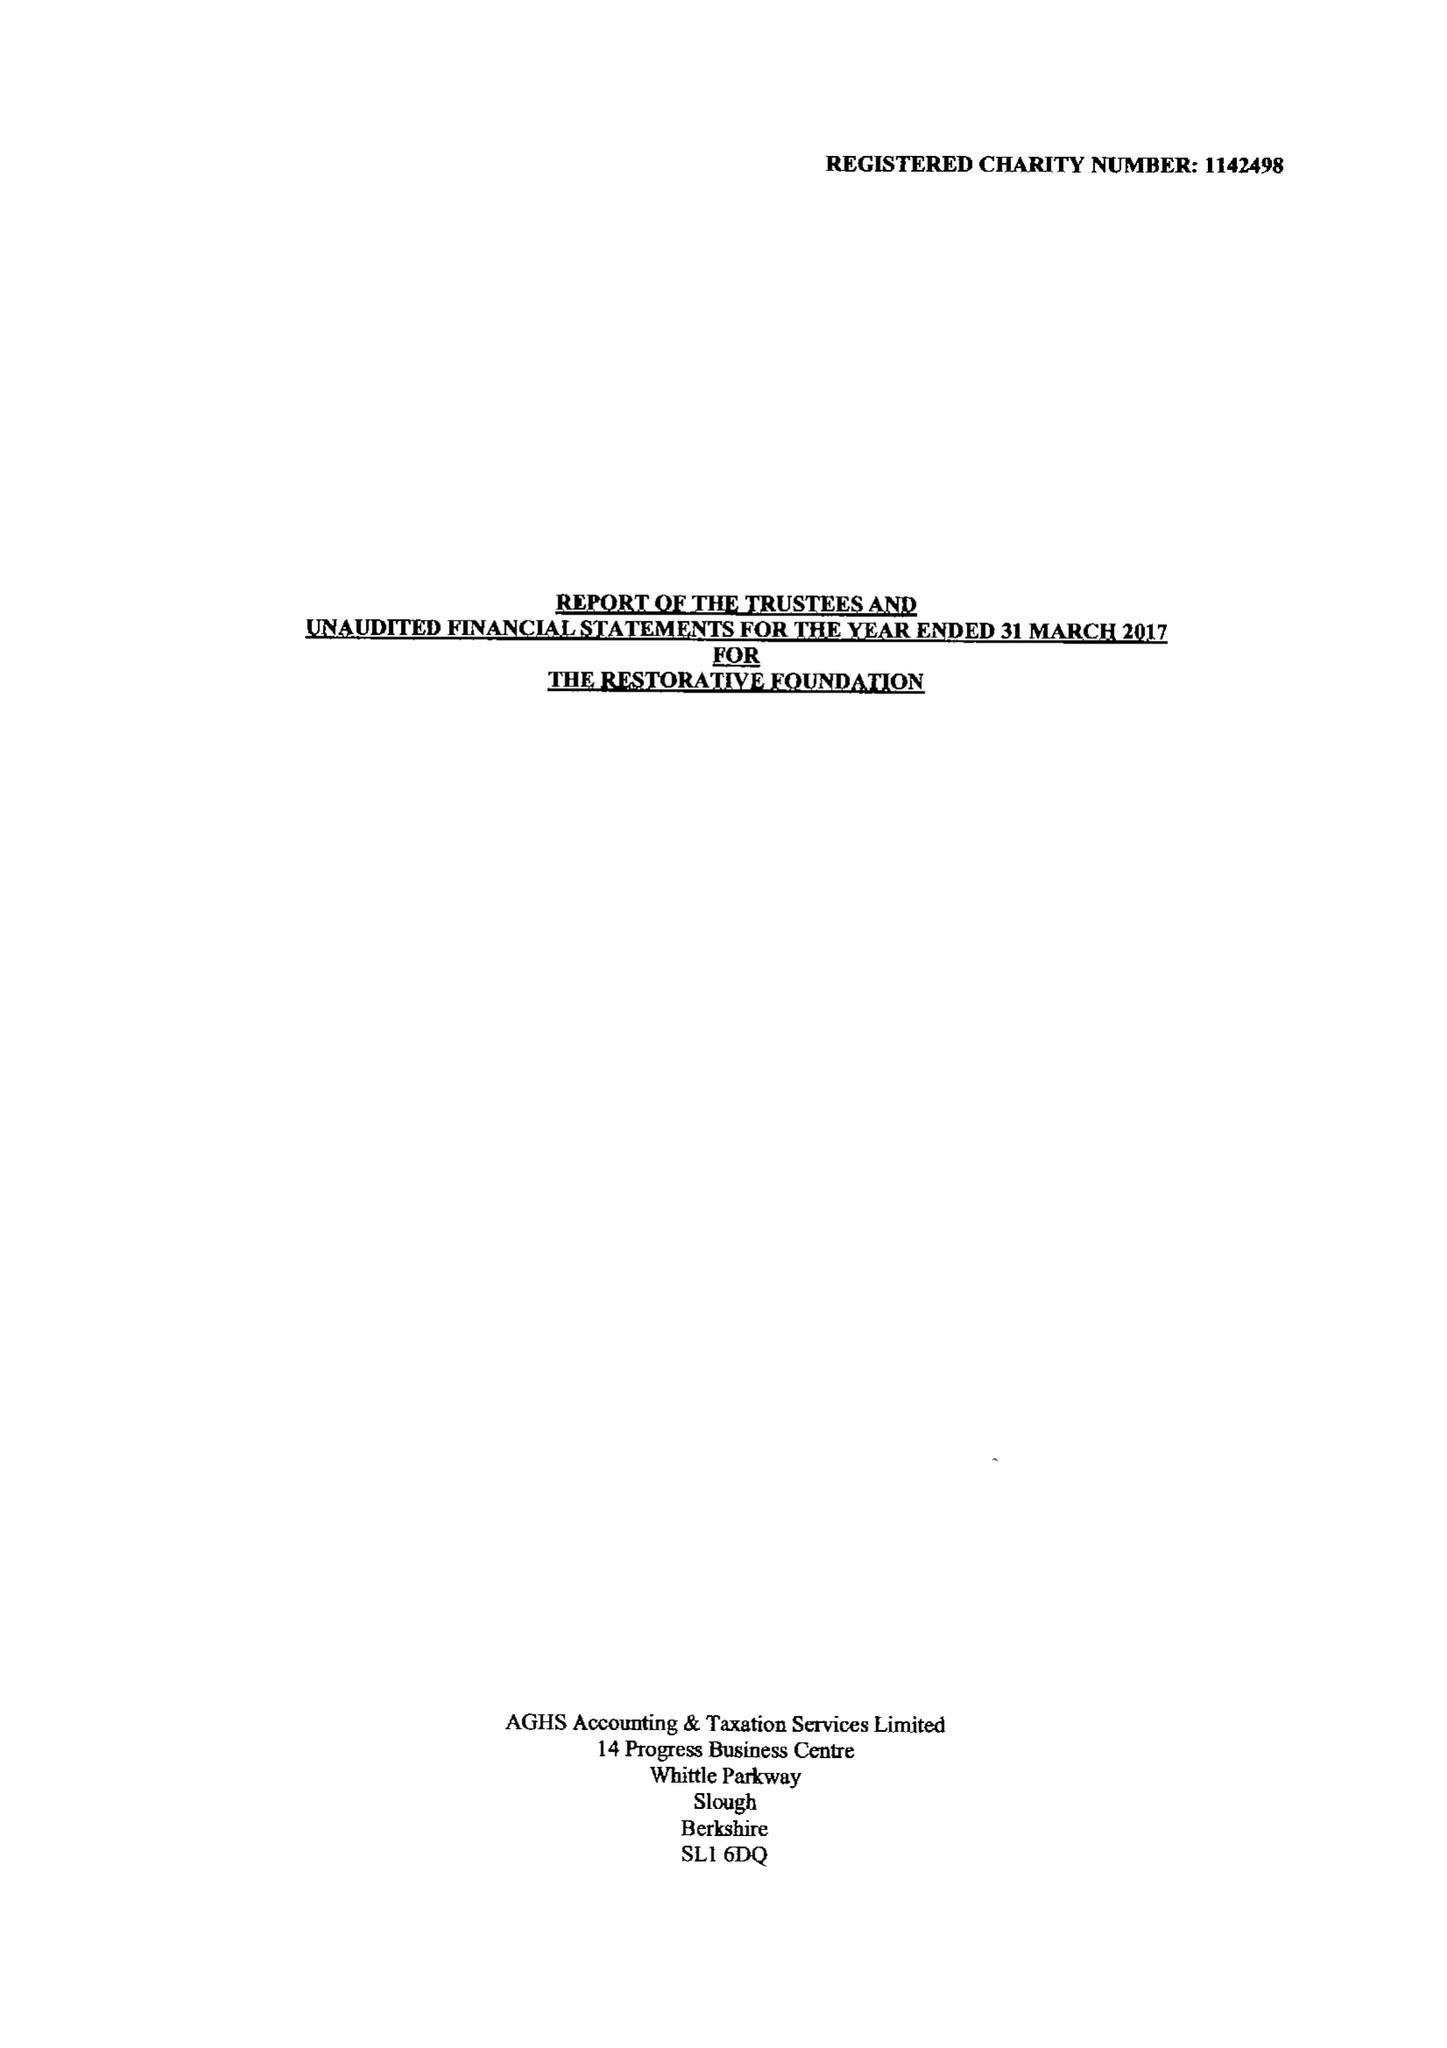What is the value for the address__street_line?
Answer the question using a single word or phrase. CRICKET FIELD ROAD 